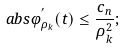<formula> <loc_0><loc_0><loc_500><loc_500>\ a b s { \varphi ^ { ^ { \prime } } _ { \rho _ { k } } } ( t ) \leq \frac { c _ { n } } { \rho ^ { 2 } _ { k } } ;</formula> 